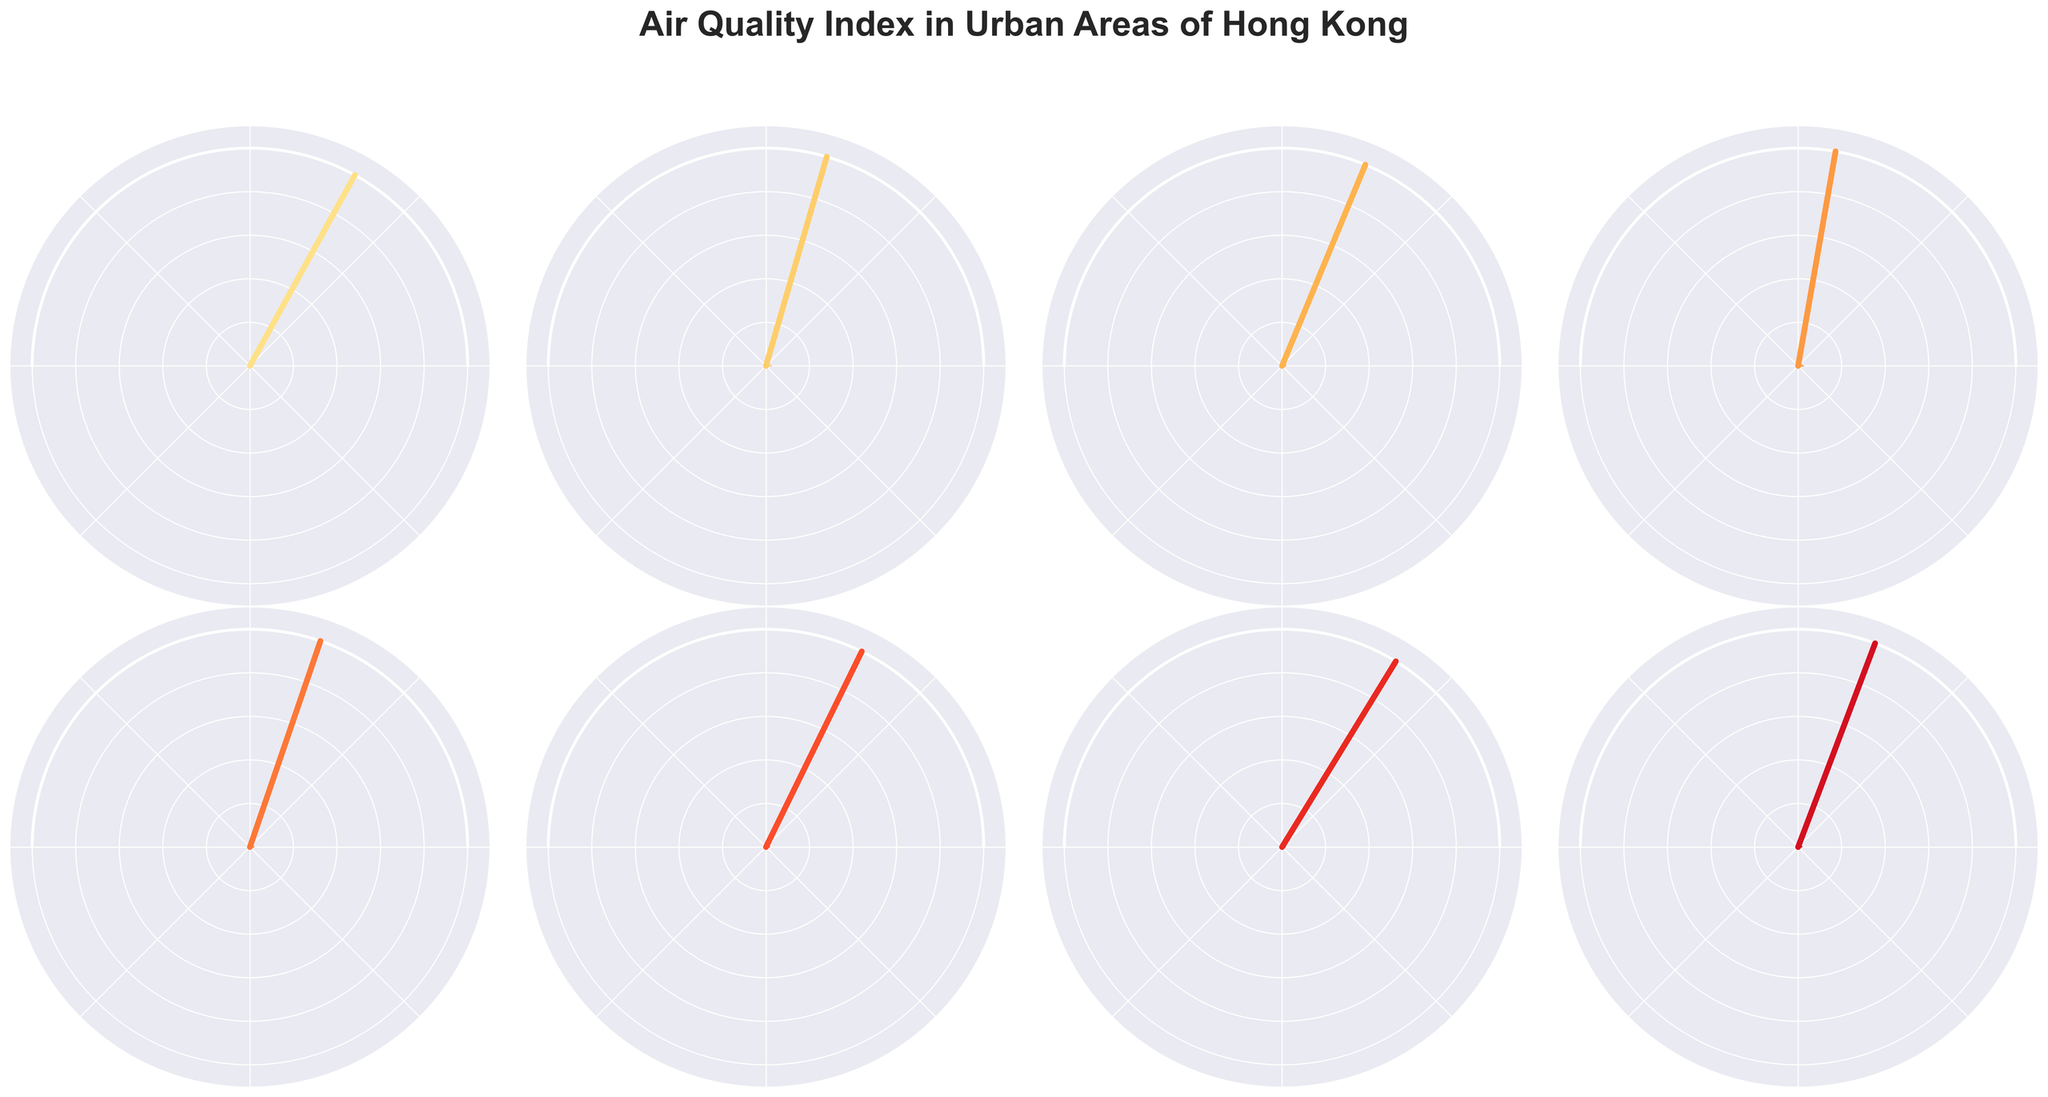What is the highest AQI value shown in the figure, and which location does it correspond to? The highest AQI value can be found by identifying the gauge chart with the needle pointing to the highest value. In this case, Kwun Tong has the highest AQI value of 89.
Answer: Kwun Tong, 89 Which location has the lowest AQI value, and what is the value? The location with the lowest AQI is Tung Chung. This is determined by finding the gauge chart with the smallest AQI value reading.
Answer: Tung Chung, 65 What is the average AQI value across all the locations? To find the average, sum all the AQI values and then divide by the number of locations: (68 + 82 + 75 + 89 + 79 + 71 + 65 + 77) / 8 = 606 / 8 = 75.75.
Answer: 75.75 How many locations have an AQI value greater than 75? Count the number of locations with AQI values exceeding 75: Mong Kok (82), Causeway Bay (75), Kwun Tong (89), Sham Shui Po (79), and Yuen Long (77), so there are 5 locations.
Answer: 5 Which two locations have the closest AQI values, and what are their values? The closest AQI values are for Causeway Bay (75) and Sham Shui Po (79), with a difference of just 4.
Answer: Causeway Bay and Sham Shui Po, 75 and 79 What is the difference between the highest and lowest AQI values? Subtract the lowest AQI value (65 for Tung Chung) from the highest AQI value (89 for Kwun Tong): 89 - 65 = 24.
Answer: 24 What is the median AQI value of all the locations? Arrange the AQI values in ascending order: 65, 68, 71, 75, 77, 79, 82, 89. The median value is the average of the 4th and 5th values in the sorted list: (75 + 77) / 2 = 76.
Answer: 76 Which locations have AQI values within 5 points of the average AQI? The average AQI is 75.75. So, locations within 5 points of this average are Causeway Bay (75), Sham Shui Po (79), Tsuen Wan (71), and Yuen Long (77).
Answer: Causeway Bay, Sham Shui Po, Tsuen Wan, Yuen Long Considering the AQI values, how many of the locations fall under the "Moderate" air quality category (51-100)? All locations fall under the "Moderate" category as their AQI values are between 51 and 100.
Answer: 8 